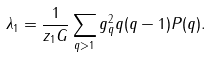Convert formula to latex. <formula><loc_0><loc_0><loc_500><loc_500>\lambda _ { 1 } = \frac { 1 } { z _ { 1 } G } \sum _ { q > 1 } g _ { q } ^ { 2 } q ( q - 1 ) P ( q ) .</formula> 